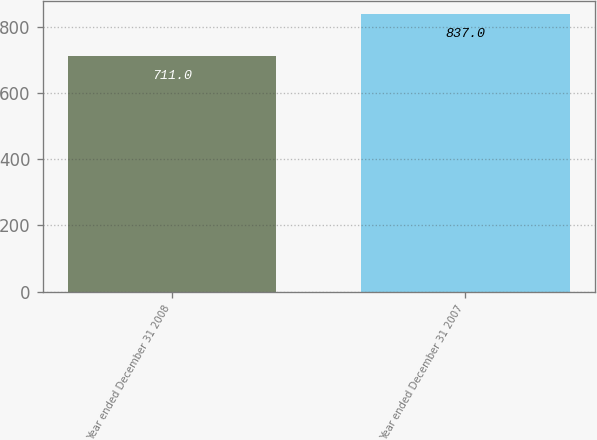<chart> <loc_0><loc_0><loc_500><loc_500><bar_chart><fcel>Year ended December 31 2008<fcel>Year ended December 31 2007<nl><fcel>711<fcel>837<nl></chart> 